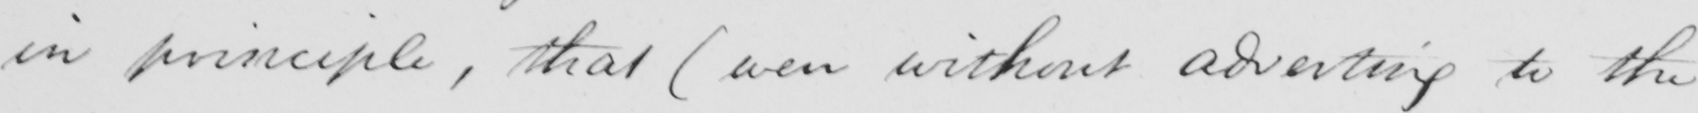What is written in this line of handwriting? in principle , that  ( even without adverting to the 